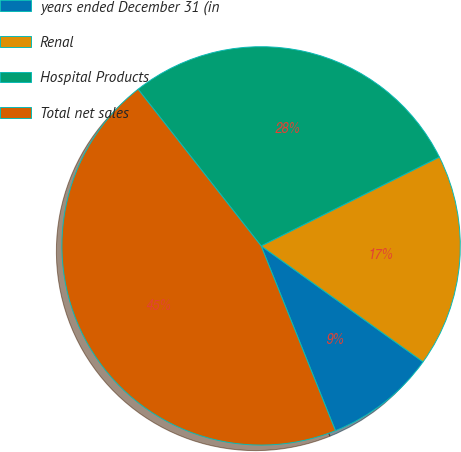Convert chart. <chart><loc_0><loc_0><loc_500><loc_500><pie_chart><fcel>years ended December 31 (in<fcel>Renal<fcel>Hospital Products<fcel>Total net sales<nl><fcel>9.02%<fcel>17.25%<fcel>28.23%<fcel>45.49%<nl></chart> 